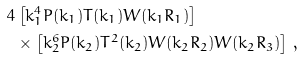<formula> <loc_0><loc_0><loc_500><loc_500>4 & \left [ k _ { 1 } ^ { 4 } P ( k _ { 1 } ) T ( k _ { 1 } ) W ( k _ { 1 } R _ { 1 } ) \right ] \, \\ & \times \left [ k _ { 2 } ^ { 6 } P ( k _ { 2 } ) T ^ { 2 } ( k _ { 2 } ) W ( k _ { 2 } R _ { 2 } ) W ( k _ { 2 } R _ { 3 } ) \right ] \, ,</formula> 